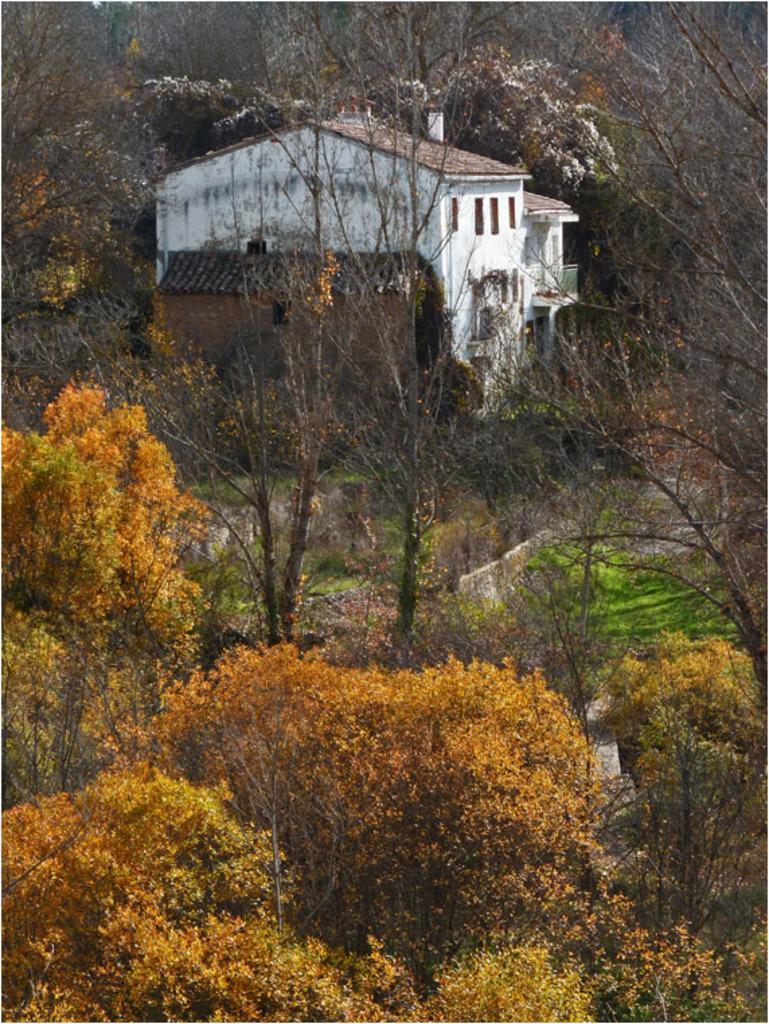How would you summarize this image in a sentence or two? In this image, we can see a house. We can see the ground and some grass. There are a few plants, trees. 